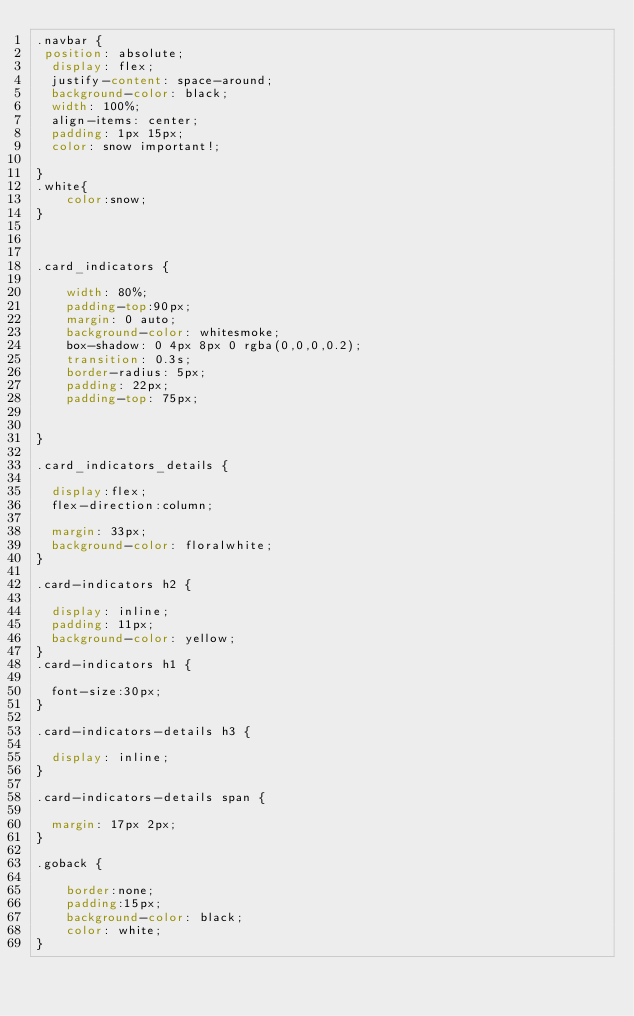Convert code to text. <code><loc_0><loc_0><loc_500><loc_500><_CSS_>.navbar {
 position: absolute;
  display: flex;
  justify-content: space-around;
  background-color: black;
  width: 100%;
  align-items: center;
  padding: 1px 15px;
  color: snow important!;

}
.white{
    color:snow;
}



.card_indicators {

    width: 80%;
    padding-top:90px;
    margin: 0 auto;
    background-color: whitesmoke;
    box-shadow: 0 4px 8px 0 rgba(0,0,0,0.2);
    transition: 0.3s;
    border-radius: 5px;
    padding: 22px;
    padding-top: 75px;


}

.card_indicators_details {

  display:flex;
  flex-direction:column;
  
  margin: 33px;
  background-color: floralwhite;
}

.card-indicators h2 {

  display: inline;
  padding: 11px;
  background-color: yellow;
}
.card-indicators h1 {

  font-size:30px;
}

.card-indicators-details h3 {

  display: inline;
}

.card-indicators-details span {

  margin: 17px 2px;
}

.goback {

    border:none;
    padding:15px;
    background-color: black;
    color: white;
}</code> 